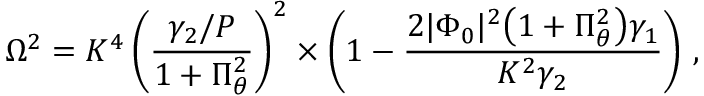<formula> <loc_0><loc_0><loc_500><loc_500>\Omega ^ { 2 } = K ^ { 4 } \left ( \frac { \gamma _ { 2 } / P } { 1 + \Pi _ { \theta } ^ { 2 } } \right ) ^ { 2 } \times \left ( 1 - \frac { 2 | \Phi _ { 0 } | ^ { 2 } \left ( 1 + \Pi _ { \theta } ^ { 2 } \right ) \gamma _ { 1 } } { K ^ { 2 } \gamma _ { 2 } } \right ) \, ,</formula> 